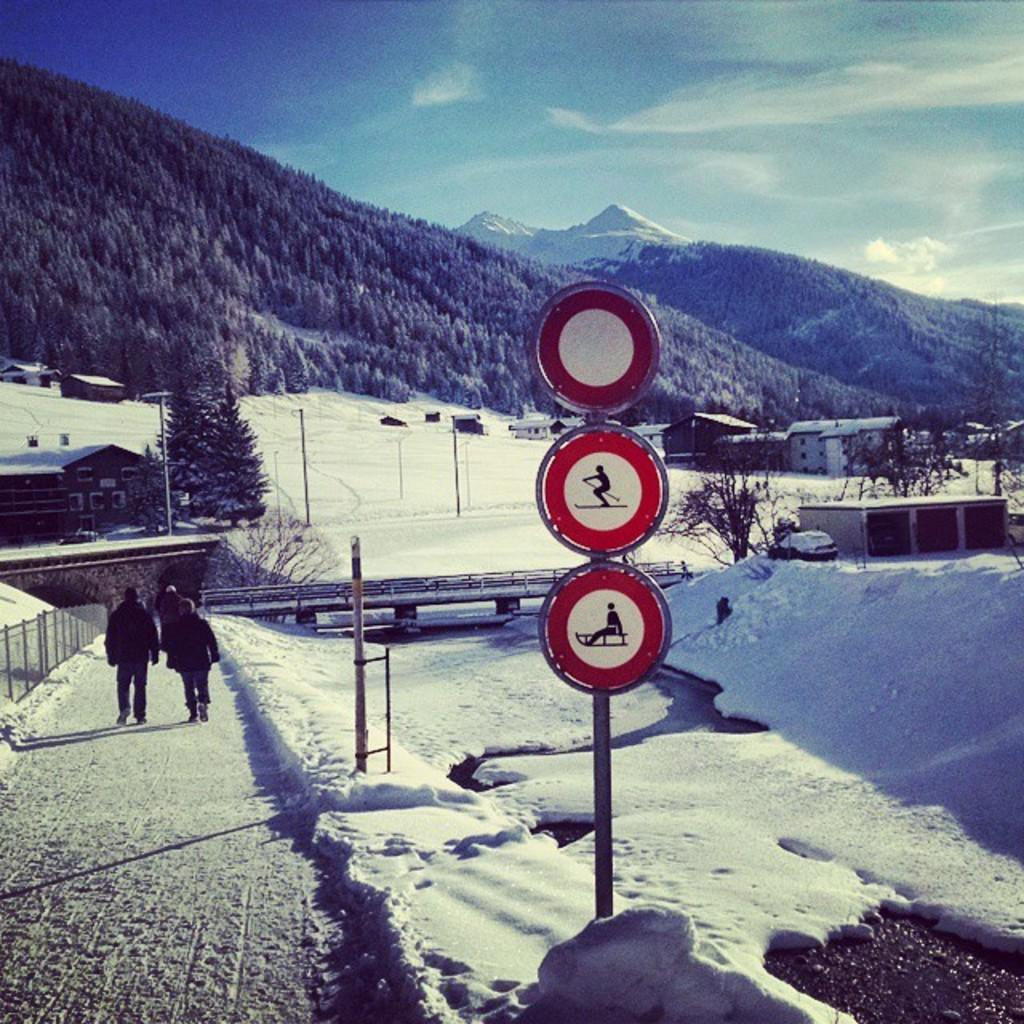What type of weather is depicted in the image? The sky is cloudy in the image. What natural elements can be seen in the image? There is snow, water, trees, and mountains in the image. What man-made structures are present in the image? There is a bridge, sign boards, poles, a vehicle, buildings, and railing in the image. Are there any people in the image? Yes, there are people in the image. What is the chance of winning the lottery in the image? There is no information about the lottery or winning chances in the image. Can you describe how the people in the image are slipping on the ice? There is no indication of anyone slipping on ice in the image. 